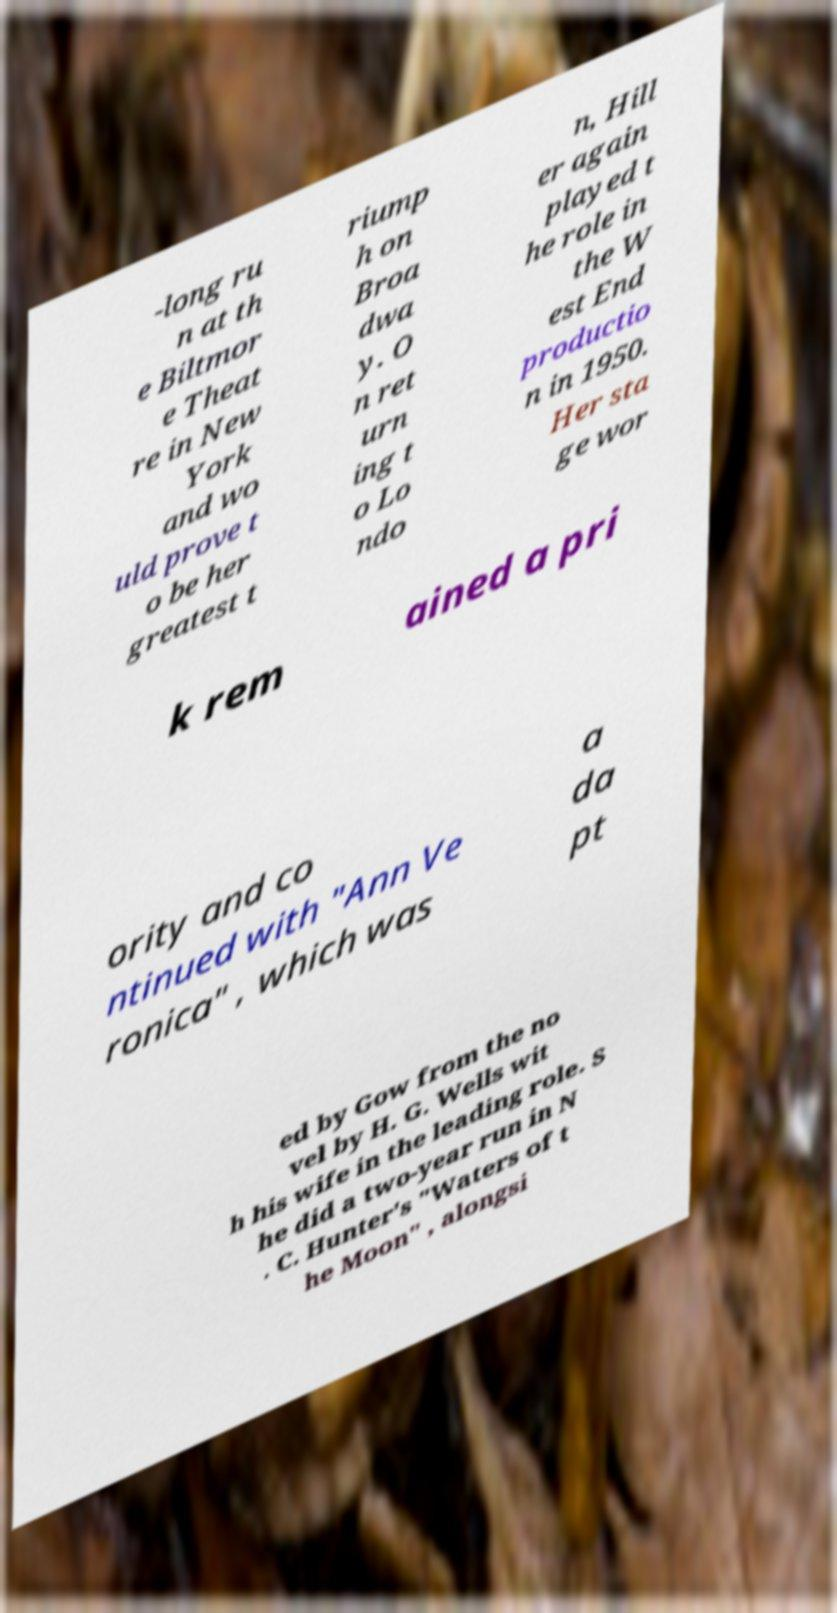Can you read and provide the text displayed in the image?This photo seems to have some interesting text. Can you extract and type it out for me? -long ru n at th e Biltmor e Theat re in New York and wo uld prove t o be her greatest t riump h on Broa dwa y. O n ret urn ing t o Lo ndo n, Hill er again played t he role in the W est End productio n in 1950. Her sta ge wor k rem ained a pri ority and co ntinued with "Ann Ve ronica" , which was a da pt ed by Gow from the no vel by H. G. Wells wit h his wife in the leading role. S he did a two-year run in N . C. Hunter's "Waters of t he Moon" , alongsi 